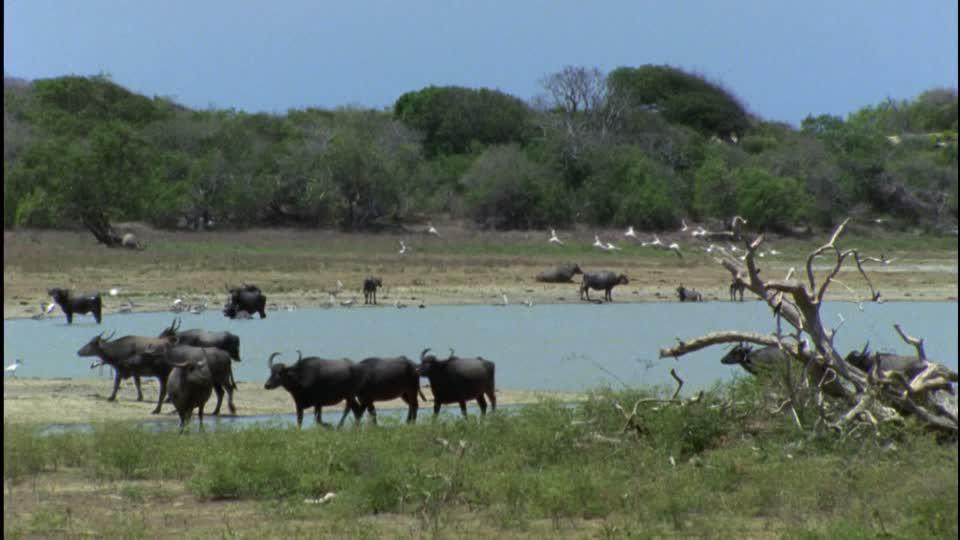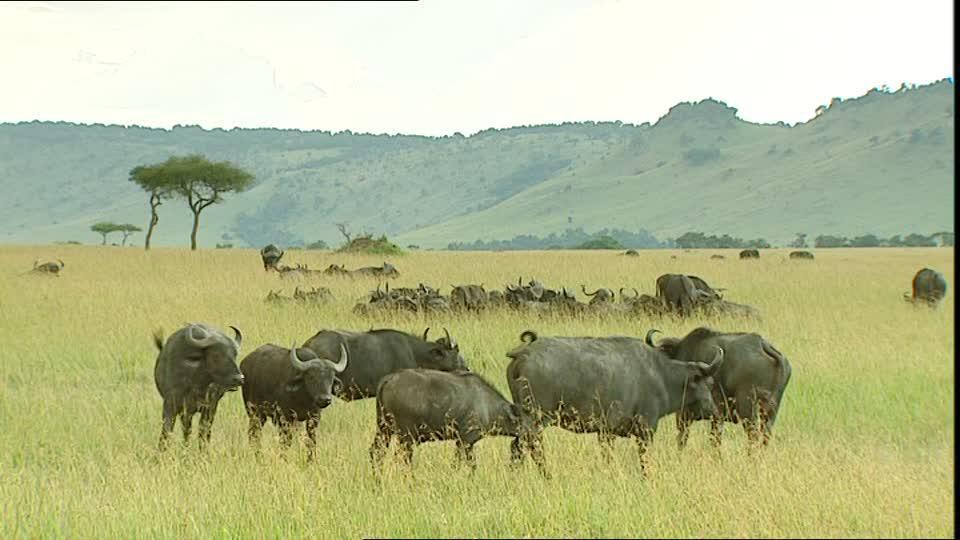The first image is the image on the left, the second image is the image on the right. Evaluate the accuracy of this statement regarding the images: "The right image shows buffalo on a green field with no water visible, and the left image shows a body of water with at least some buffalo in it, and trees behind it.". Is it true? Answer yes or no. Yes. 